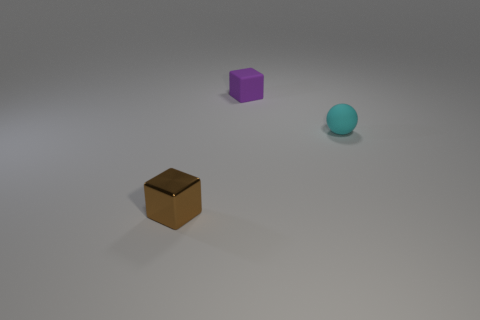How many objects are both left of the tiny purple rubber cube and behind the tiny shiny block?
Your answer should be very brief. 0. There is a purple thing that is the same size as the cyan ball; what is its shape?
Your answer should be very brief. Cube. What is the material of the small thing on the right side of the block that is on the right side of the tiny block that is in front of the cyan rubber thing?
Provide a short and direct response. Rubber. What color is the object that is the same material as the tiny cyan ball?
Provide a succinct answer. Purple. There is a small object that is on the right side of the small cube behind the small brown metallic object; how many purple objects are in front of it?
Give a very brief answer. 0. Is there any other thing that has the same shape as the cyan matte thing?
Provide a short and direct response. No. What number of things are rubber things behind the tiny cyan thing or small brown things?
Give a very brief answer. 2. What is the shape of the rubber object that is to the left of the thing on the right side of the purple matte object?
Your answer should be very brief. Cube. Are there fewer small purple rubber things that are behind the small rubber block than small purple things behind the cyan ball?
Provide a short and direct response. Yes. How many objects are small matte objects on the left side of the small cyan matte ball or small things behind the small shiny object?
Your answer should be very brief. 2. 